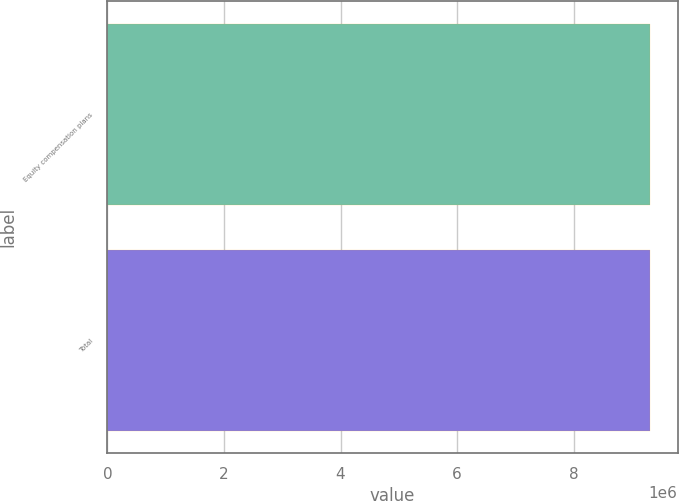Convert chart. <chart><loc_0><loc_0><loc_500><loc_500><bar_chart><fcel>Equity compensation plans<fcel>Total<nl><fcel>9.31964e+06<fcel>9.31964e+06<nl></chart> 